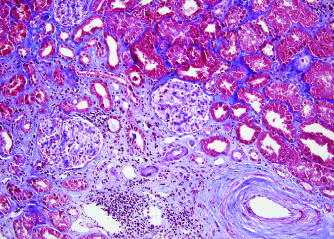s an artery showing prominent arteriosclerosis shown (bottom right)?
Answer the question using a single word or phrase. Yes 